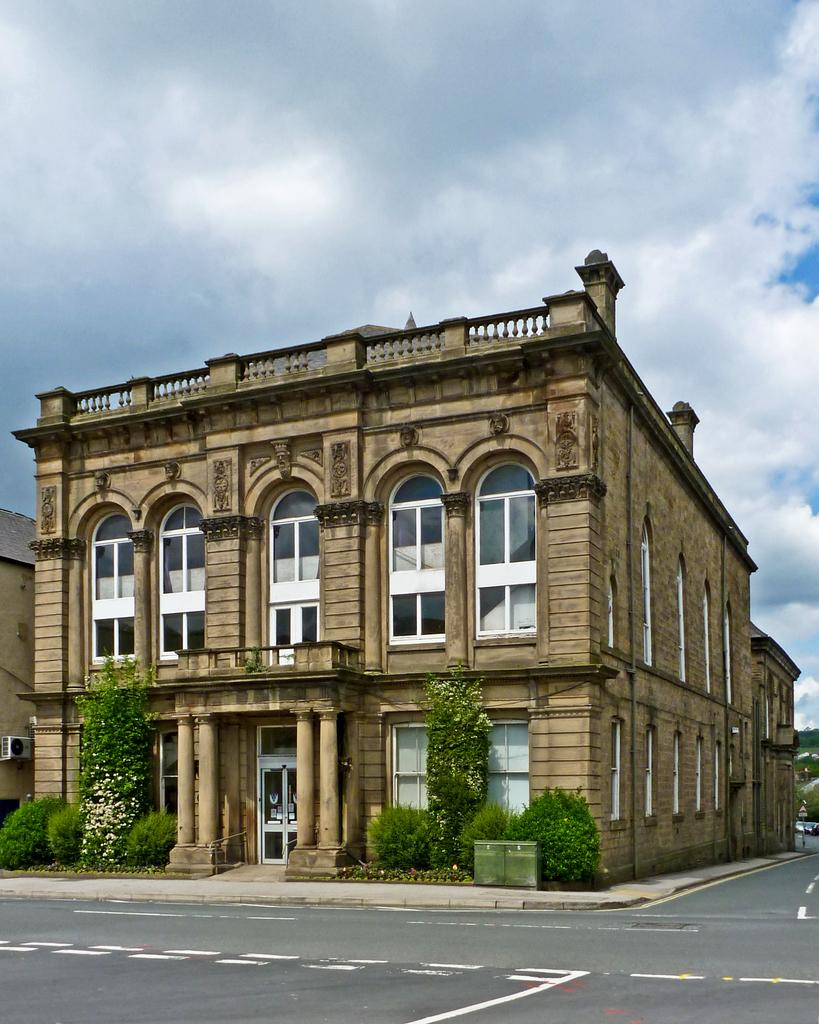What type of structures can be seen in the image? There are buildings in the image. What other natural elements are present in the image? There are trees and plants in the image. How would you describe the sky in the image? The sky is blue and cloudy in the image. How many pockets can be seen on the trees in the image? There are no pockets present on the trees in the image, as trees do not have pockets. 